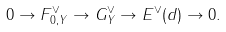<formula> <loc_0><loc_0><loc_500><loc_500>0 \to F _ { 0 , Y } ^ { \vee } \to G _ { Y } ^ { \vee } \to E ^ { \vee } ( d ) \to 0 .</formula> 